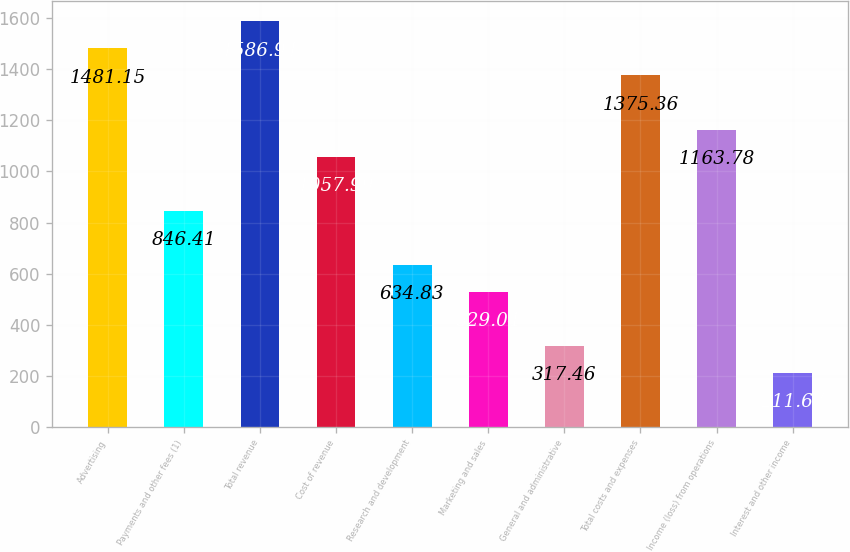<chart> <loc_0><loc_0><loc_500><loc_500><bar_chart><fcel>Advertising<fcel>Payments and other fees (1)<fcel>Total revenue<fcel>Cost of revenue<fcel>Research and development<fcel>Marketing and sales<fcel>General and administrative<fcel>Total costs and expenses<fcel>Income (loss) from operations<fcel>Interest and other income<nl><fcel>1481.15<fcel>846.41<fcel>1586.94<fcel>1057.99<fcel>634.83<fcel>529.04<fcel>317.46<fcel>1375.36<fcel>1163.78<fcel>211.67<nl></chart> 